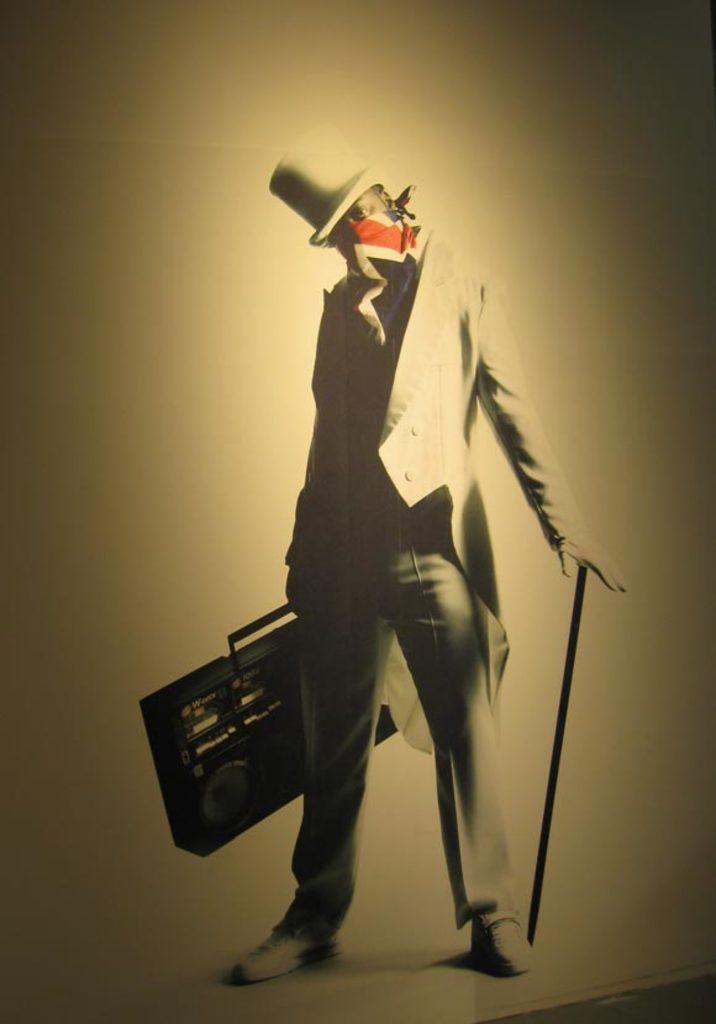Describe this image in one or two sentences. In the center of the image, we can see a person standing and wearing a coat, scarf and a hat and holding a radio and a stick. In the background, there is a wall. 